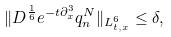Convert formula to latex. <formula><loc_0><loc_0><loc_500><loc_500>\| D ^ { \frac { 1 } { 6 } } e ^ { - t \partial _ { x } ^ { 3 } } q _ { n } ^ { N } \| _ { L ^ { 6 } _ { t , x } } \leq \delta ,</formula> 